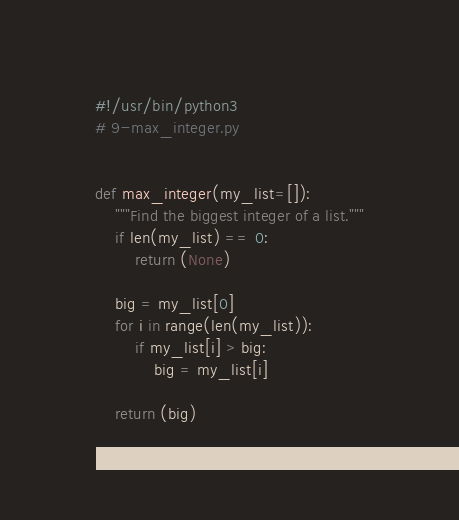Convert code to text. <code><loc_0><loc_0><loc_500><loc_500><_Python_>#!/usr/bin/python3
# 9-max_integer.py


def max_integer(my_list=[]):
    """Find the biggest integer of a list."""
    if len(my_list) == 0:
        return (None)

    big = my_list[0]
    for i in range(len(my_list)):
        if my_list[i] > big:
            big = my_list[i]

    return (big)
</code> 